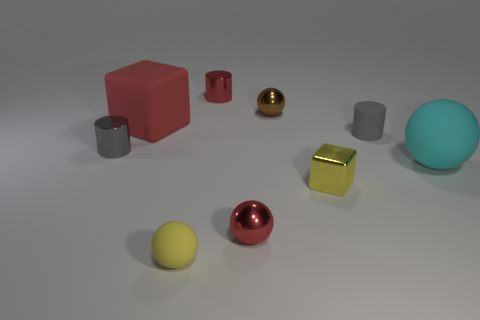Subtract all large matte balls. How many balls are left? 3 Add 1 gray shiny things. How many objects exist? 10 Subtract all gray cylinders. How many cylinders are left? 1 Subtract 2 blocks. How many blocks are left? 0 Add 8 big red rubber things. How many big red rubber things are left? 9 Add 9 large red matte objects. How many large red matte objects exist? 10 Subtract 1 red blocks. How many objects are left? 8 Subtract all spheres. How many objects are left? 5 Subtract all cyan cylinders. Subtract all yellow balls. How many cylinders are left? 3 Subtract all yellow balls. How many gray cylinders are left? 2 